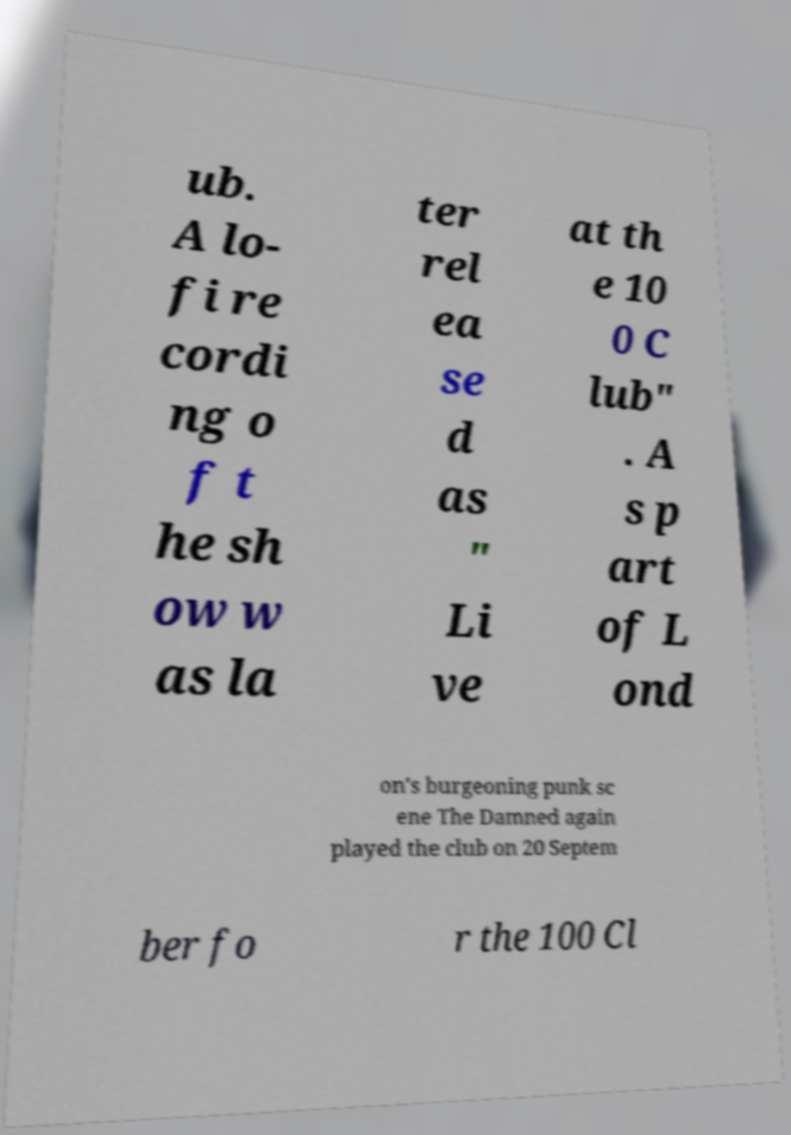Could you extract and type out the text from this image? ub. A lo- fi re cordi ng o f t he sh ow w as la ter rel ea se d as " Li ve at th e 10 0 C lub" . A s p art of L ond on's burgeoning punk sc ene The Damned again played the club on 20 Septem ber fo r the 100 Cl 